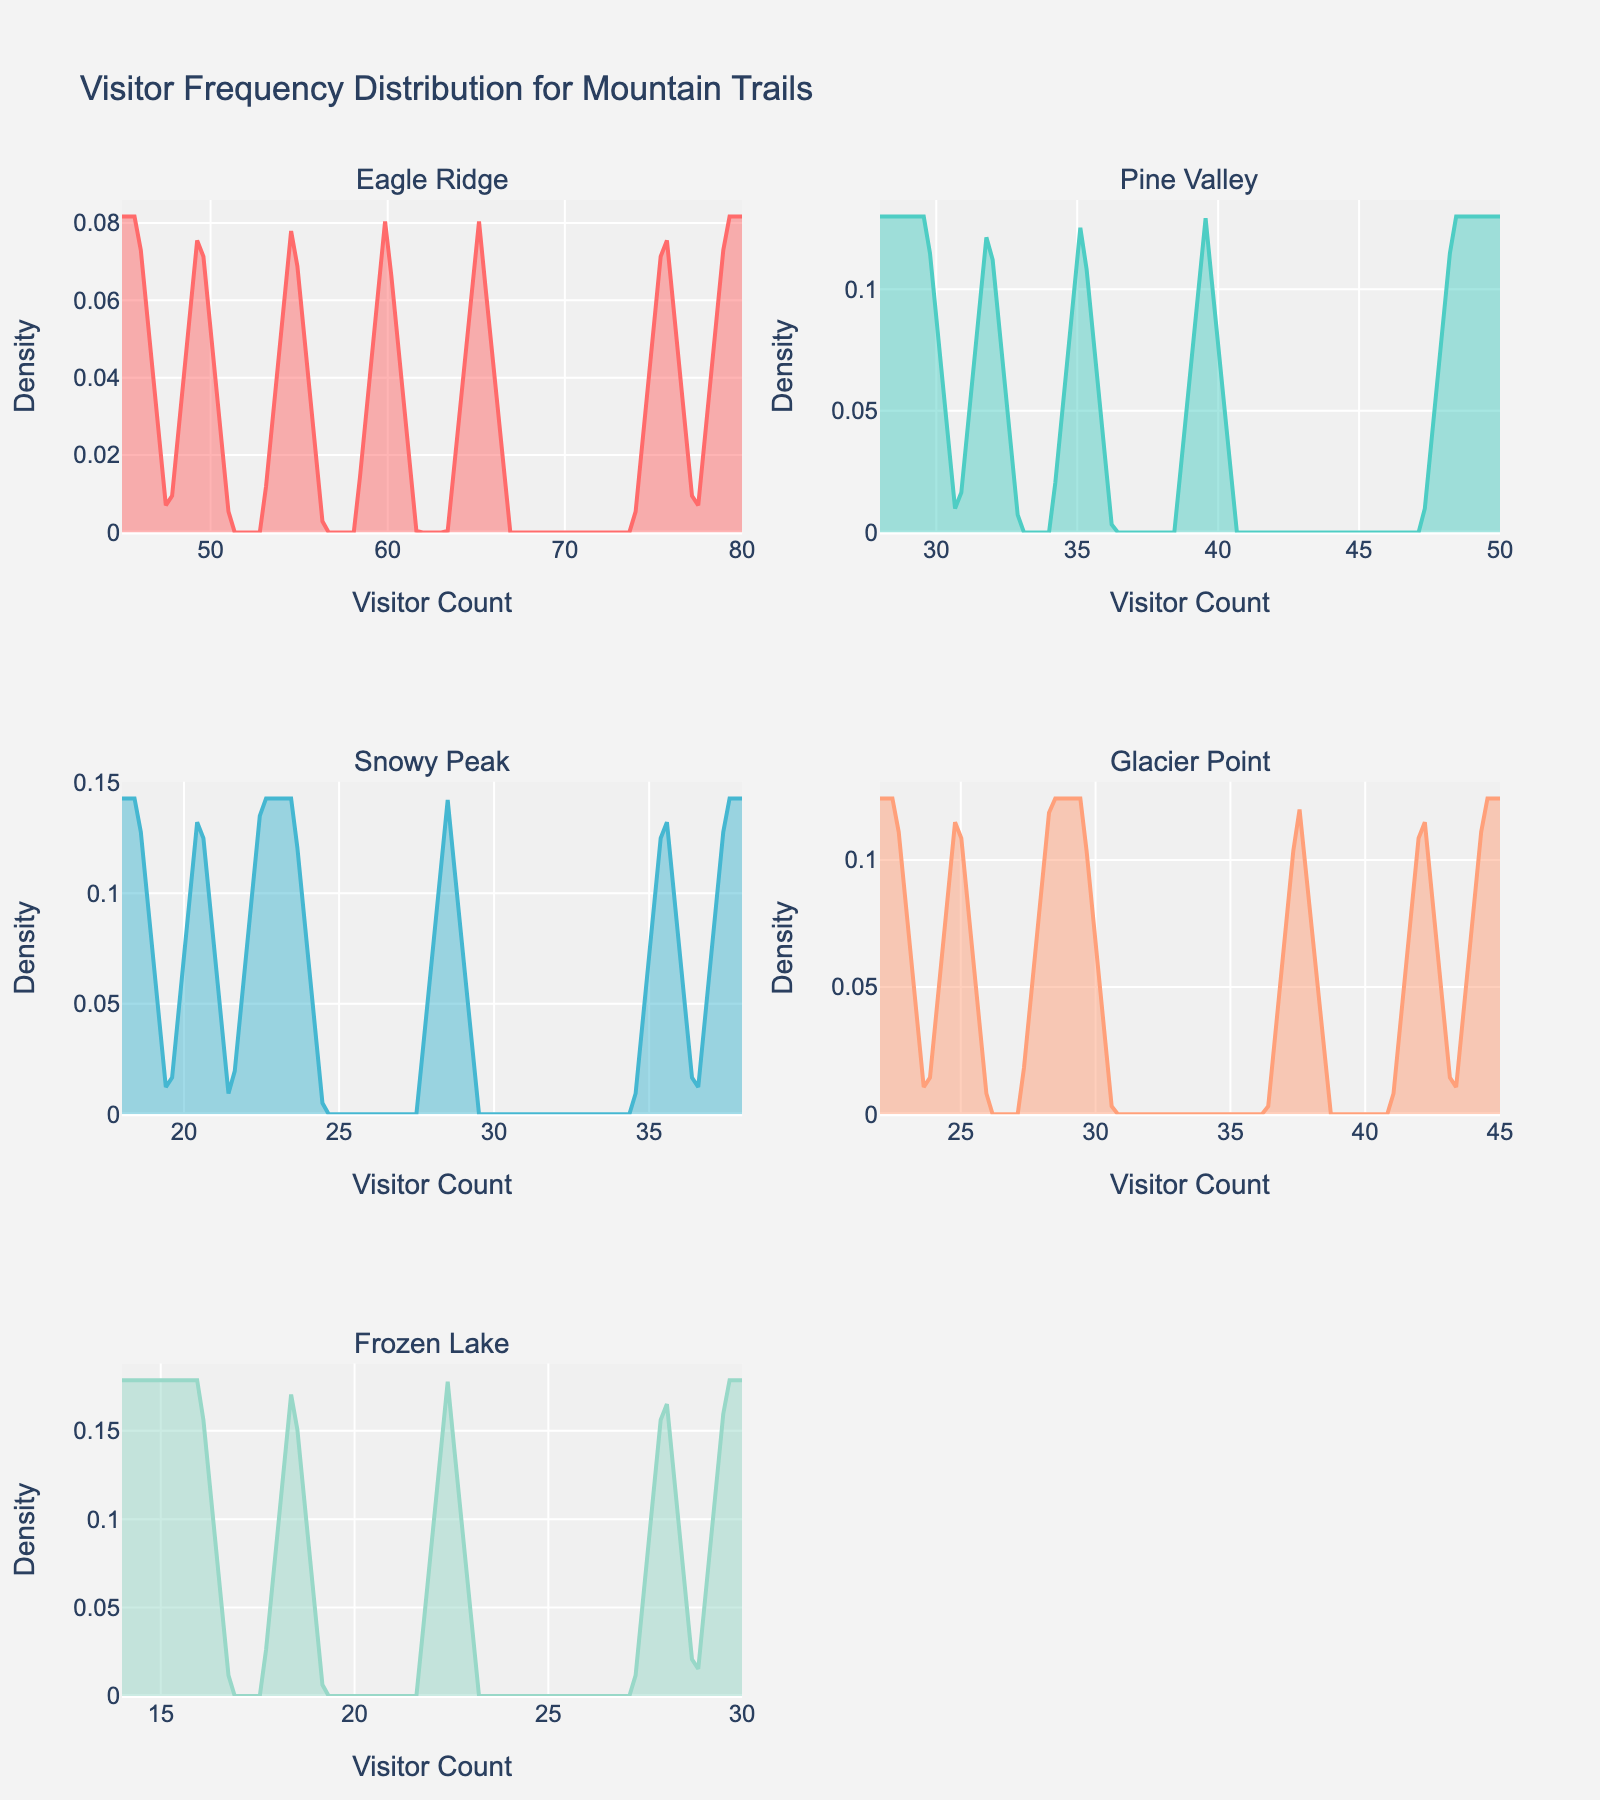What's the title of the figure? The title is usually found at the top of the figure and it provides a summary of what the figure represents. In this case, it is "Visitor Frequency Distribution for Mountain Trails".
Answer: Visitor Frequency Distribution for Mountain Trails What does the x-axis represent? The x-axis, labeled as 'Visitor Count', shows the number of visitors for each trail. This indicates how visitor counts vary across different days for each trail.
Answer: Visitor Count How many trails are shown in the figure? The subplot titles give us the names of the trails. There are five unique trail names represented in the subplots.
Answer: 5 Which trail has the highest peak in its density curve? By examining the density curves in each subplot, the trail with the highest peak would have the tallest curve. In this case, Eagle Ridge has the highest peak.
Answer: Eagle Ridge Between Pine Valley and Snowy Peak, which trail has more consistent visitor counts? Consistency can be inferred from a narrow and high density curve, indicating less variability. Snowy Peak's curve is narrower and more consistent compared to Pine Valley.
Answer: Snowy Peak On which days do Eagle Ridge and Pine Valley appear to have the highest visitor density? By looking at the peaks of the density curves for each trail, we see that the highest density is reached on weekends (Saturday and Sunday) for both Eagle Ridge and Pine Valley.
Answer: Saturday and Sunday Which trail shows a peak visitor count lower than 20? Frozen Lake's density curve peaks below 20 Visitor Counts, indicating that it has the lowest visitor count among the trails.
Answer: Frozen Lake Compare Glacier Point and Frozen Lake; which trail shows a wider distribution of visitor counts? A wider distribution is demonstrated by a flatter and more spread-out density curve. Glacier Point shows a broader spread compared to Frozen Lake.
Answer: Glacier Point What might be a reason for the lower visitor counts in Frozen Lake compared to Eagle Ridge? Generally speaking, lower visitor counts could be due to less popular attractions, more difficult terrain, or less accessible locations. Comparing to Eagle Ridge, Frozen Lake may be less appealing or harder to access.
Answer: Less popular attractions, more difficult terrain, or less accessible locations 